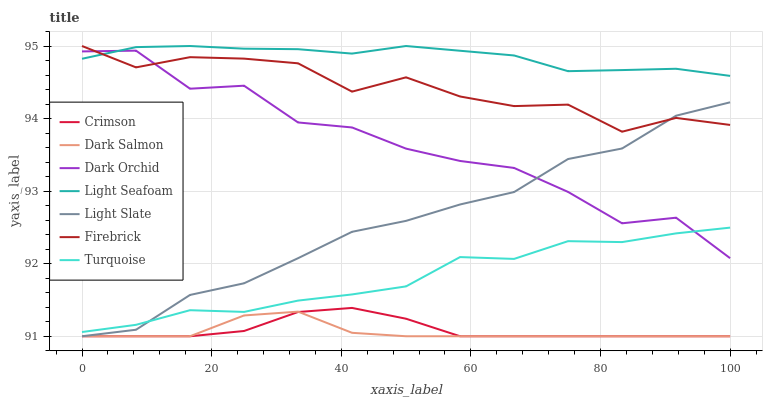Does Dark Salmon have the minimum area under the curve?
Answer yes or no. Yes. Does Light Seafoam have the maximum area under the curve?
Answer yes or no. Yes. Does Light Slate have the minimum area under the curve?
Answer yes or no. No. Does Light Slate have the maximum area under the curve?
Answer yes or no. No. Is Crimson the smoothest?
Answer yes or no. Yes. Is Dark Orchid the roughest?
Answer yes or no. Yes. Is Light Slate the smoothest?
Answer yes or no. No. Is Light Slate the roughest?
Answer yes or no. No. Does Firebrick have the lowest value?
Answer yes or no. No. Does Light Seafoam have the highest value?
Answer yes or no. Yes. Does Light Slate have the highest value?
Answer yes or no. No. Is Crimson less than Turquoise?
Answer yes or no. Yes. Is Turquoise greater than Dark Salmon?
Answer yes or no. Yes. Does Light Slate intersect Dark Orchid?
Answer yes or no. Yes. Is Light Slate less than Dark Orchid?
Answer yes or no. No. Is Light Slate greater than Dark Orchid?
Answer yes or no. No. Does Crimson intersect Turquoise?
Answer yes or no. No. 